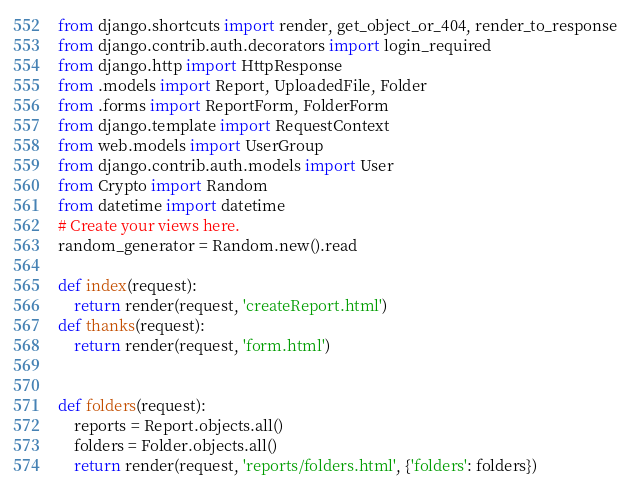Convert code to text. <code><loc_0><loc_0><loc_500><loc_500><_Python_>from django.shortcuts import render, get_object_or_404, render_to_response
from django.contrib.auth.decorators import login_required
from django.http import HttpResponse
from .models import Report, UploadedFile, Folder
from .forms import ReportForm, FolderForm
from django.template import RequestContext
from web.models import UserGroup
from django.contrib.auth.models import User
from Crypto import Random
from datetime import datetime
# Create your views here.
random_generator = Random.new().read

def index(request):
    return render(request, 'createReport.html')
def thanks(request):
    return render(request, 'form.html')


def folders(request):
    reports = Report.objects.all()
    folders = Folder.objects.all()
    return render(request, 'reports/folders.html', {'folders': folders})
</code> 